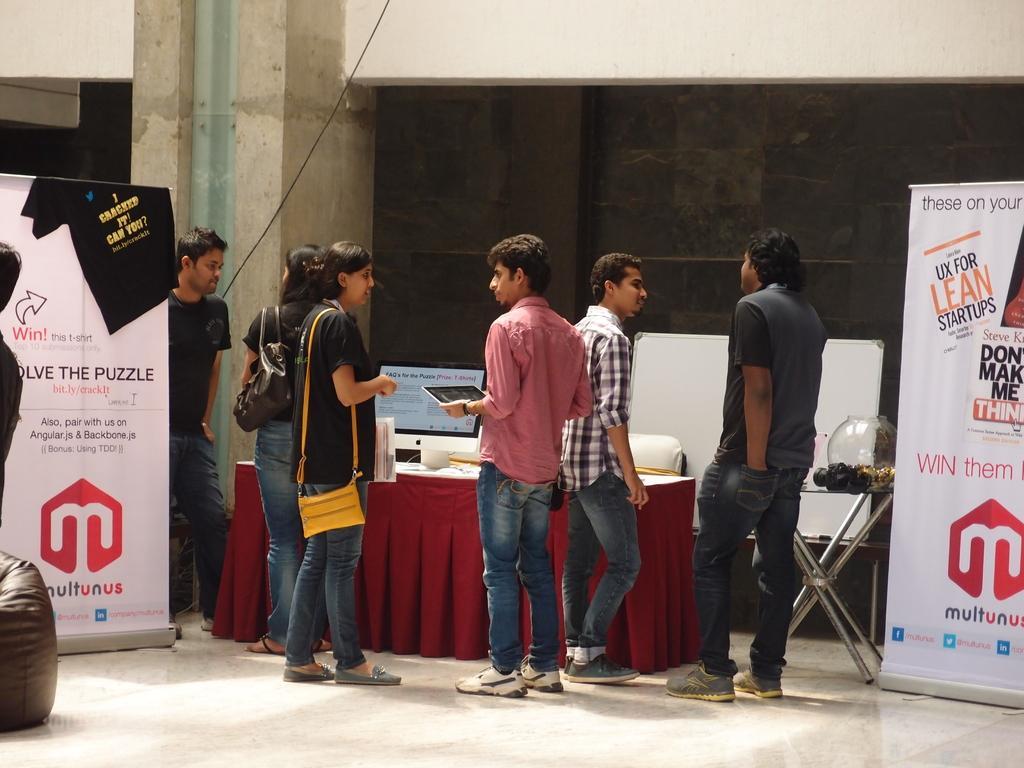Could you give a brief overview of what you see in this image? In the image there are few people standing on the floor in front of table with a desktop on it, on either sides there are banners and on the left side there is a pillar, over the background its a wall. 